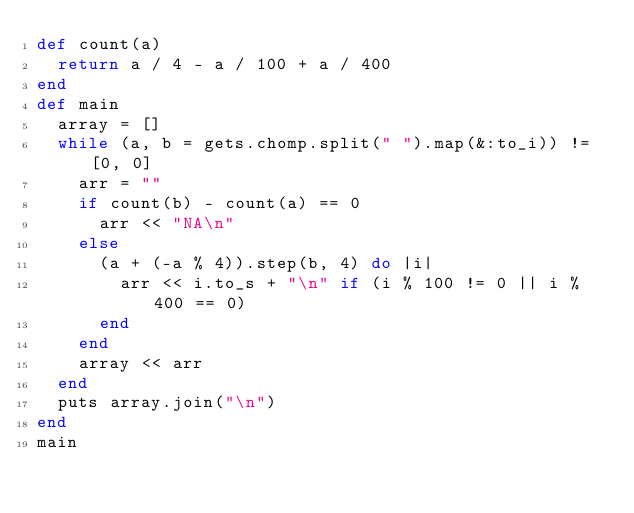<code> <loc_0><loc_0><loc_500><loc_500><_Ruby_>def count(a)
  return a / 4 - a / 100 + a / 400
end
def main
  array = []
  while (a, b = gets.chomp.split(" ").map(&:to_i)) != [0, 0]
    arr = ""
    if count(b) - count(a) == 0
      arr << "NA\n"
    else
      (a + (-a % 4)).step(b, 4) do |i|
        arr << i.to_s + "\n" if (i % 100 != 0 || i % 400 == 0)
      end
    end
    array << arr
  end
  puts array.join("\n")
end
main</code> 